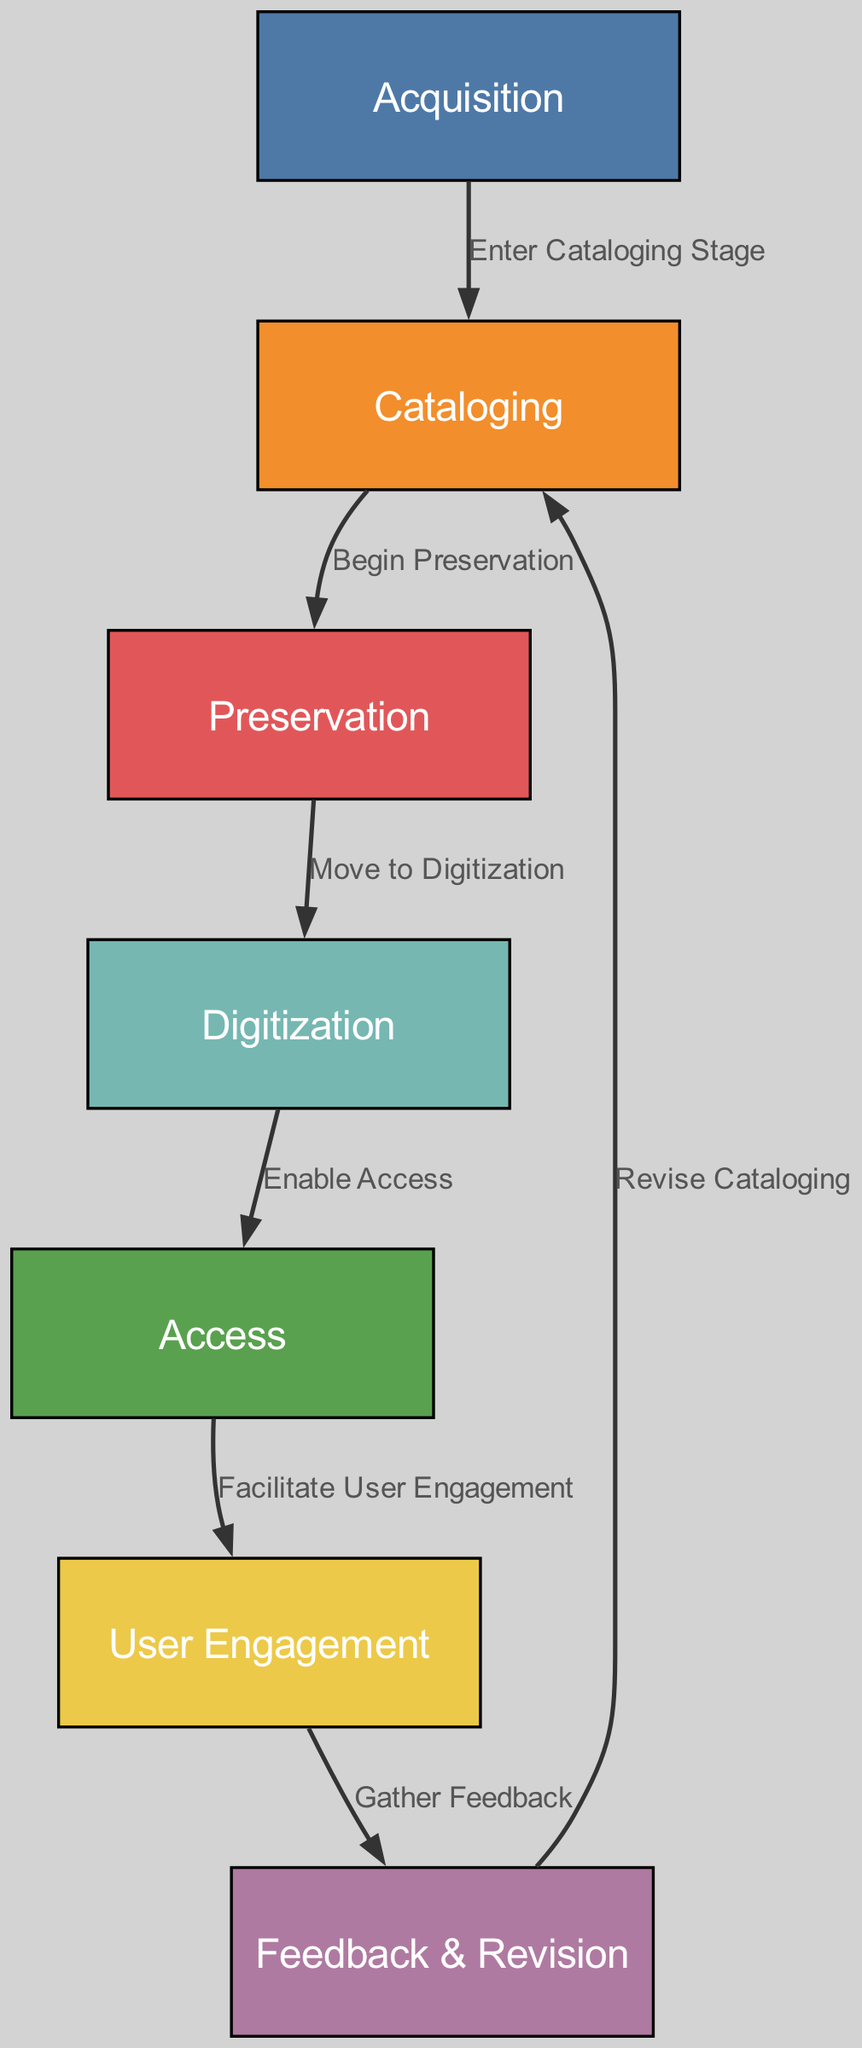What is the first stage in the lifecycle? The first node in the diagram is labeled "Acquisition," indicating that it's the starting point for the lifecycle of library archival materials.
Answer: Acquisition How many total stages are there in the lifecycle? By counting the nodes labeled in the diagram, there are seven identifiable stages present.
Answer: Seven Which stage follows Cataloging? According to the diagram, the edge from the "Cataloging" node points to the "Preservation" node, indicating that Preservation is the next stage.
Answer: Preservation What is the final stage before Feedback & Revision? The “User Engagement” stage is followed directly by the “Feedback & Revision” stage, as represented by the edge connecting these two nodes.
Answer: User Engagement What relationship exists between Preservation and Digitization? The diagram shows an arrow from the "Preservation" node to the "Digitization" node, with the label "Move to Digitization," indicating a direct connection between them.
Answer: Move to Digitization What is the process after User Engagement? After User Engagement, the process moves to Feedback & Revision, as indicated by the edge that links these two stages.
Answer: Feedback & Revision How does the process start again after Revision? The edge labeled "Revise Cataloging" indicates that the process loops back from Feedback & Revision to Cataloging, thus restarting the lifecycle.
Answer: Revise Cataloging How many edges connect the stages in the lifecycle? There are six edges connecting the seven stages, as counted in the diagram, indicating the flow of the lifecycle.
Answer: Six What is the role of the Access stage? The "Access" stage facilitates further user engagement in the lifecycle, as shown by the edge directed towards the User Engagement node.
Answer: Facilitate User Engagement 